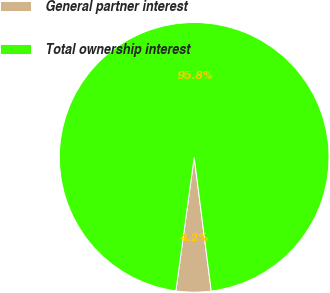Convert chart. <chart><loc_0><loc_0><loc_500><loc_500><pie_chart><fcel>General partner interest<fcel>Total ownership interest<nl><fcel>4.19%<fcel>95.81%<nl></chart> 